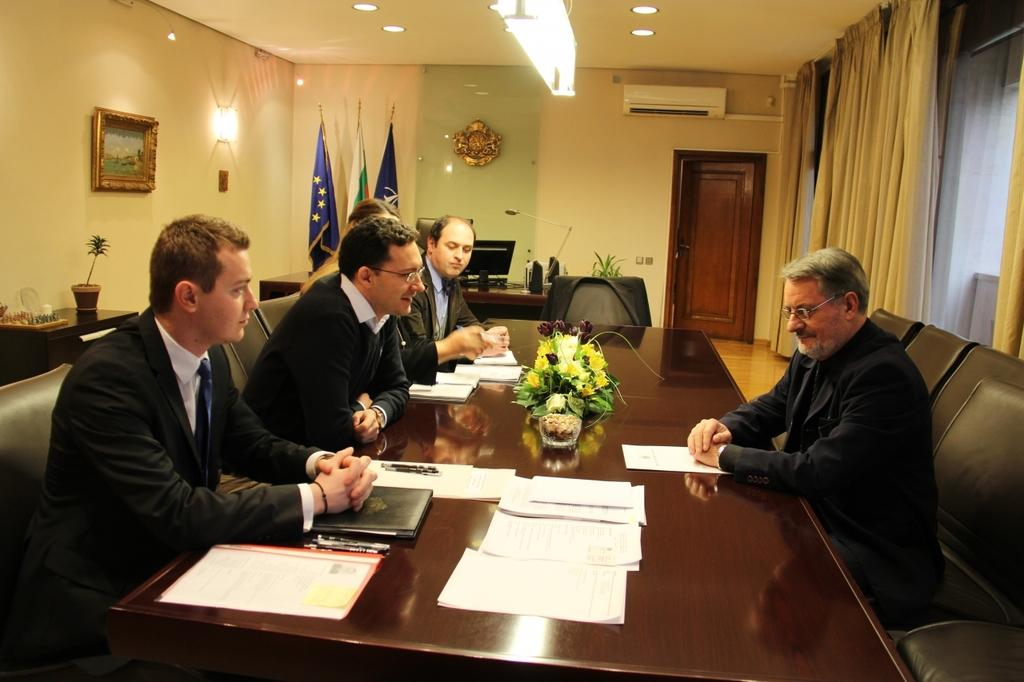What are the people in the image doing? The people in the image are sitting on chairs. What is present on the table in the image? There are flowers and a paper on the table. What other objects can be seen in the image? There are flags and a door in the image. What type of bird is sitting on the father's shoulder in the image? There is no father or bird present in the image. What is being exchanged between the people in the image? The image does not show any exchange of items or actions between the people. 